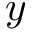Convert formula to latex. <formula><loc_0><loc_0><loc_500><loc_500>y</formula> 